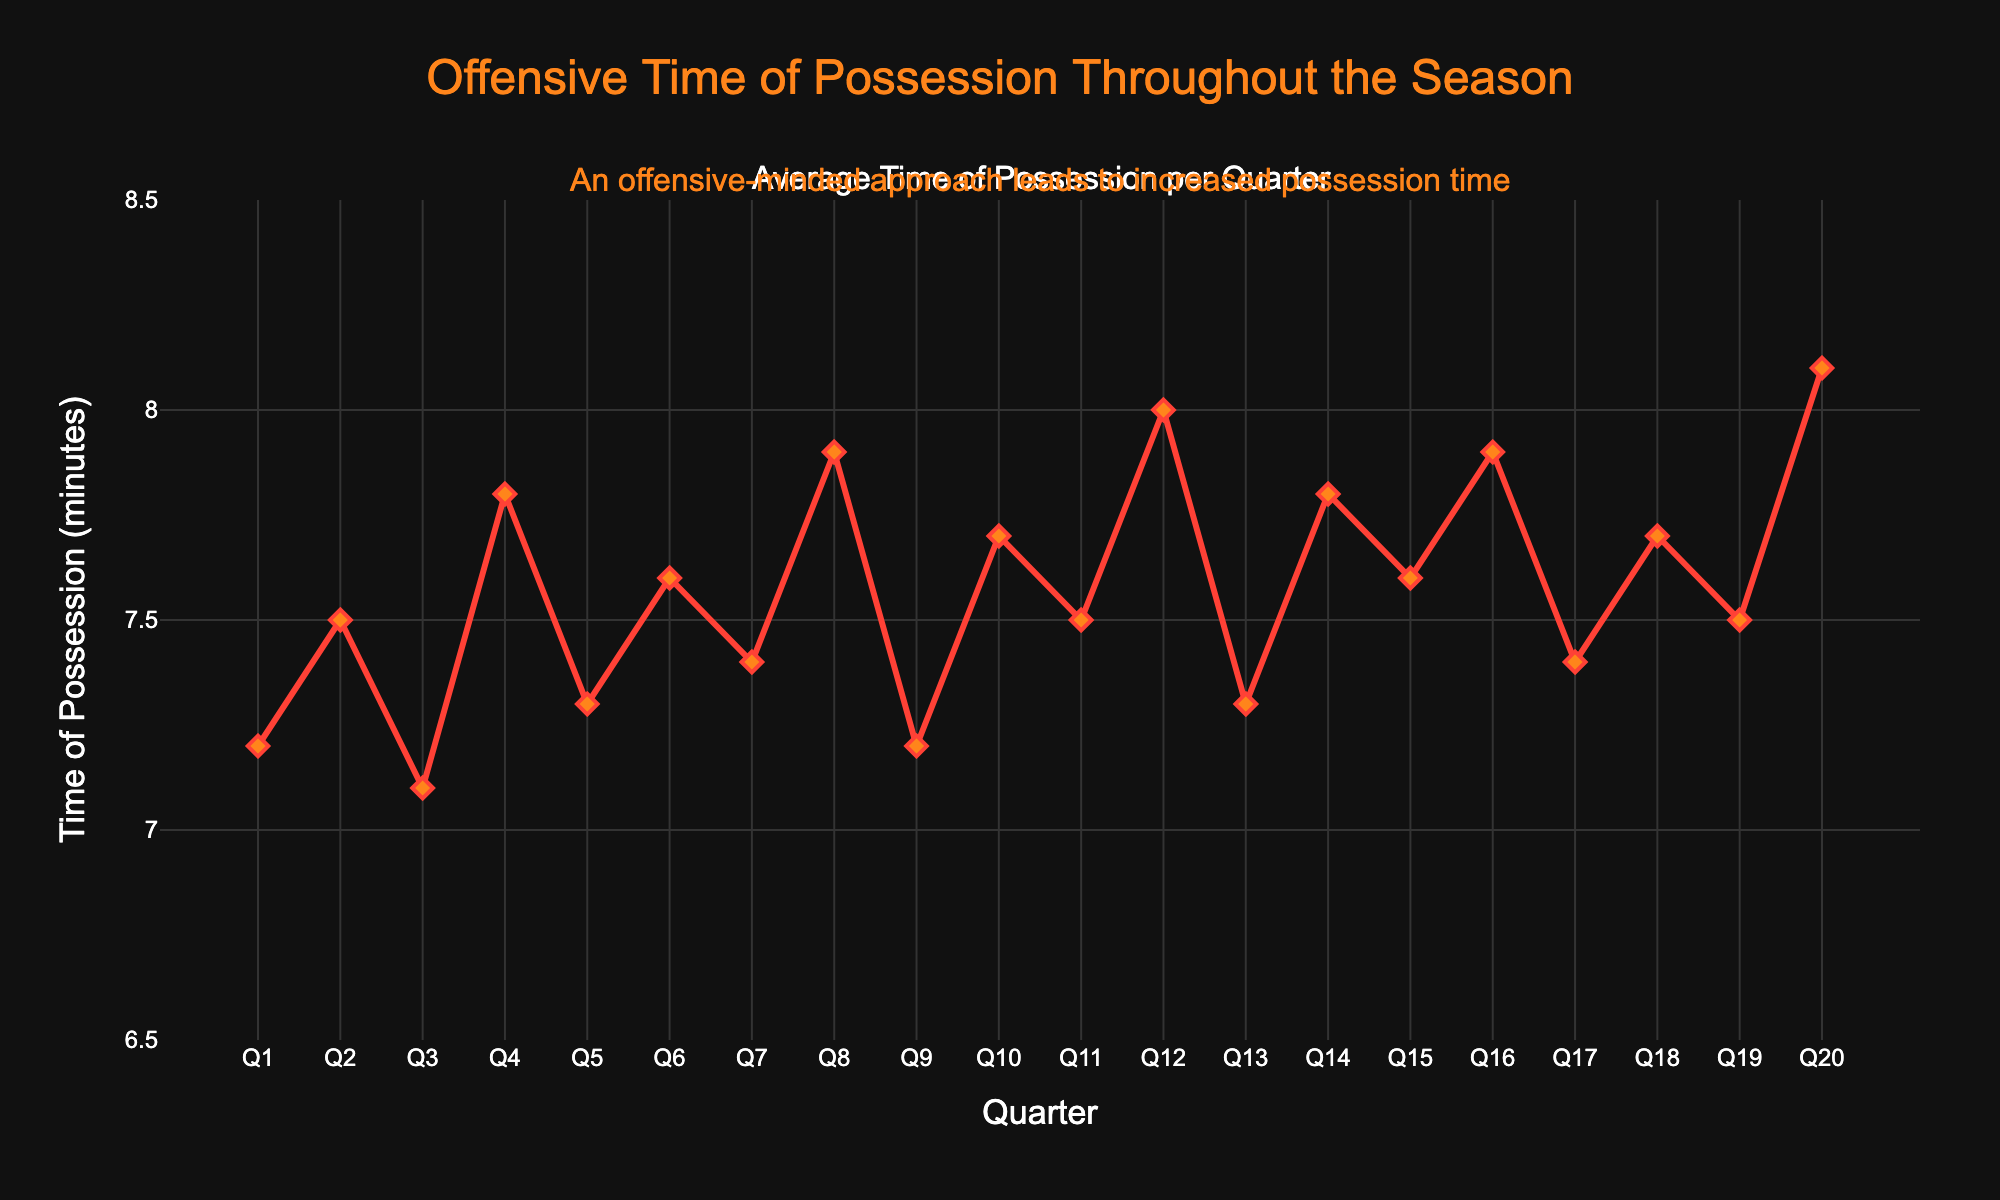What is the average time of possession in the first half of the season (Q1 to Q10)? To find the average, sum up the values from Q1 to Q10 and divide by 10. The values are 7.2, 7.5, 7.1, 7.8, 7.3, 7.6, 7.4, 7.9, 7.2, 7.7. Sum them to get 75.7 and divide by 10.
Answer: 7.57 Which quarter had the highest average time of possession? Look at the highest point on the line chart. The highest value in the dataset is 8.1, which occurs in Q20.
Answer: Q20 How does the time of possession in Q8 compare to Q12? Compare the values of Q8 and Q12 directly from the chart. Q8 has 7.9 minutes, and Q12 has 8.0 minutes; Q12 is slightly higher.
Answer: Q12 > Q8 What is the difference in time of possession between Q20 and Q1? Subtract the value of Q1 from Q20. Q20 is 8.1 minutes, and Q1 is 7.2 minutes; hence the difference is 8.1 - 7.2.
Answer: 0.9 Which quarters have a time of possession less than 7.5 minutes? Visually identify the quarters where the time of possession falls below 7.5. These are Q1, Q3, Q5, Q9, and Q13.
Answer: Q1, Q3, Q5, Q9, Q13 What is the median time of possession for the entire season? Arrange the data in ascending order and find the middle value. The data in ascending order: 7.1, 7.2, 7.2, 7.3, 7.3, 7.4, 7.4, 7.5, 7.5, 7.5, 7.6, 7.6, 7.7, 7.7, 7.8, 7.8, 7.9, 7.9, 8.0, 8.1. The median value is the average of the 10th and 11th values, which are 7.5 and 7.6. Hence, the median is (7.5 + 7.6) / 2.
Answer: 7.55 What trend can be observed about time of possession over the quarters? Look at the pattern of the line chart; the general trend shows fluctuations but remains within a narrow range between 7.1 and 8.1 minutes.
Answer: Fluctuating but generally consistent During which quarters did the time of possession increase compared to the previous quarter? Compare each consecutive pair of quarters. Time of possession increases at Q2, Q4, Q6, Q8, Q10, Q12, Q14, Q16, Q18, and Q20.
Answer: Q2, Q4, Q6, Q8, Q10, Q12, Q14, Q16, Q18, Q20 What is the total time of possession across all quarters in the season? Sum all the values from Q1 to Q20. Summing the given values: 7.2 + 7.5 + 7.1 + 7.8 + 7.3 + 7.6 + 7.4 + 7.9 + 7.2 + 7.7 + 7.5 + 8.0 + 7.3 + 7.8 + 7.6 + 7.9 + 7.4 + 7.7 + 7.5 + 8.1 to get 152.5 minutes.
Answer: 152.5 minutes 